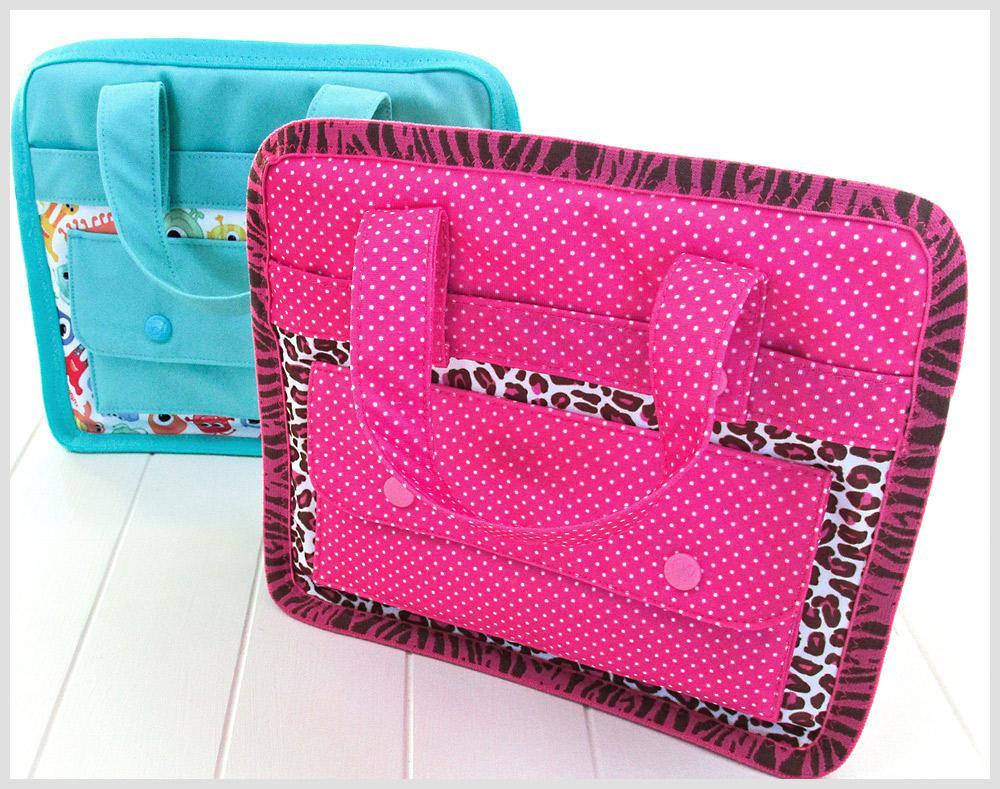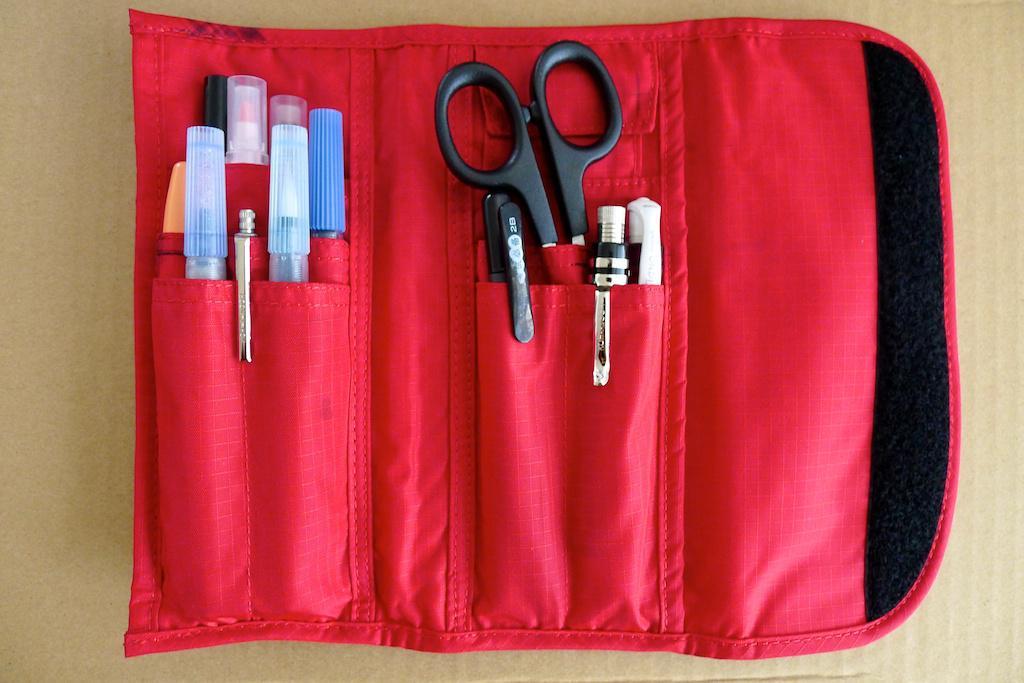The first image is the image on the left, the second image is the image on the right. Evaluate the accuracy of this statement regarding the images: "An image shows two closed fabric cases, one pink and one blue.". Is it true? Answer yes or no. Yes. The first image is the image on the left, the second image is the image on the right. Analyze the images presented: Is the assertion "Every pouch has eyes." valid? Answer yes or no. No. 